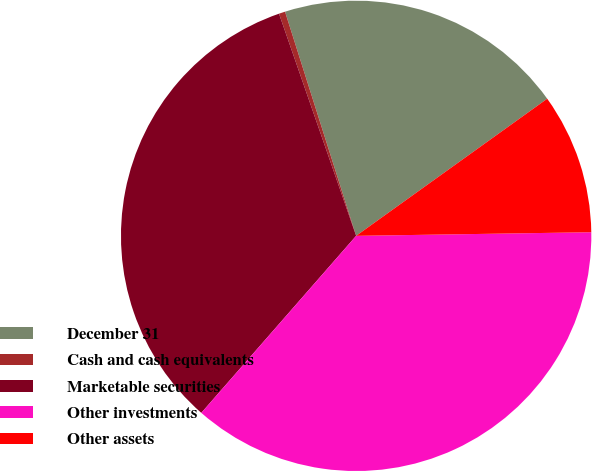Convert chart. <chart><loc_0><loc_0><loc_500><loc_500><pie_chart><fcel>December 31<fcel>Cash and cash equivalents<fcel>Marketable securities<fcel>Other investments<fcel>Other assets<nl><fcel>19.98%<fcel>0.43%<fcel>33.24%<fcel>36.68%<fcel>9.66%<nl></chart> 